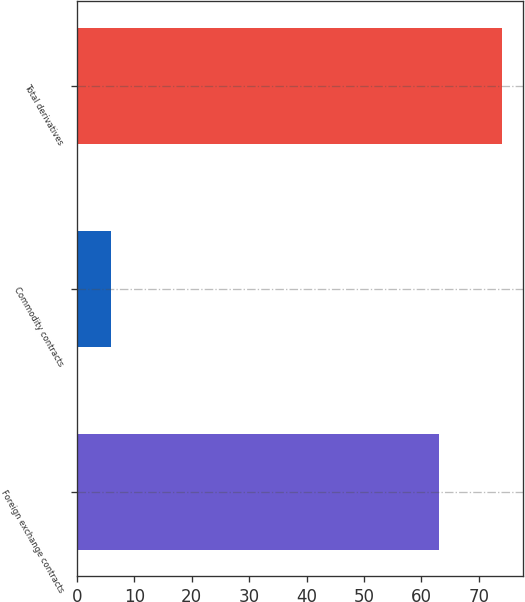<chart> <loc_0><loc_0><loc_500><loc_500><bar_chart><fcel>Foreign exchange contracts<fcel>Commodity contracts<fcel>Total derivatives<nl><fcel>63<fcel>6<fcel>74<nl></chart> 